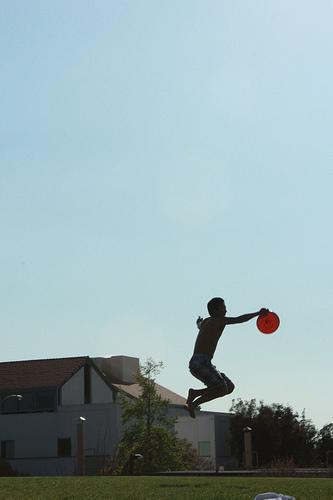How many people are there?
Give a very brief answer. 1. 